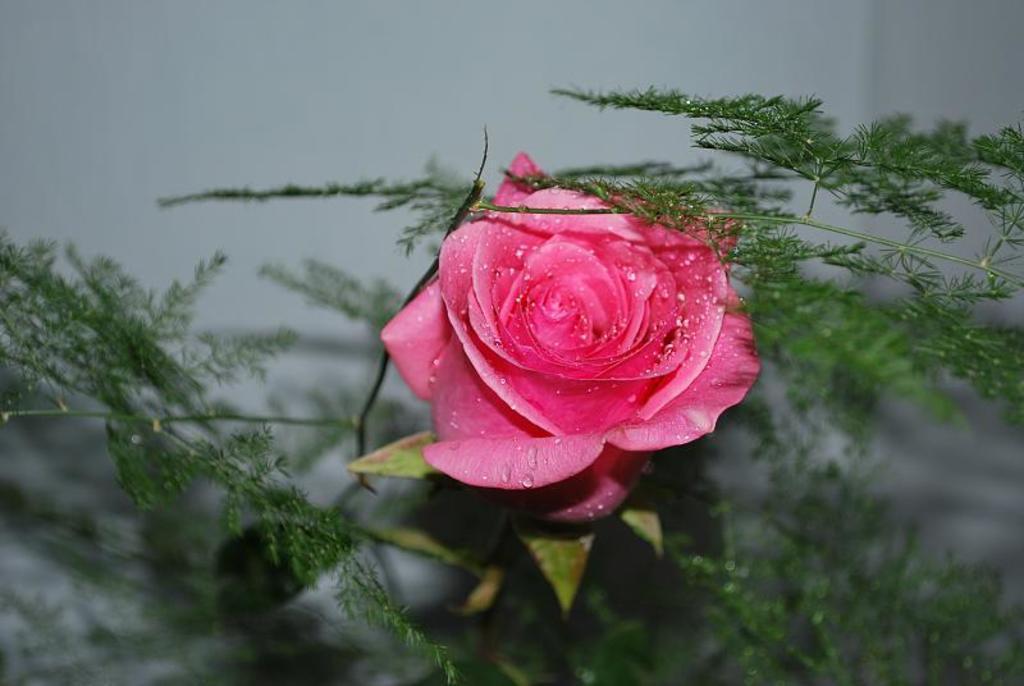Describe this image in one or two sentences. In this picture there is a pink rose flower on the plant. In the foreground there are other plants and there are water droplets on the flower. At the back there is a wall. 